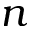Convert formula to latex. <formula><loc_0><loc_0><loc_500><loc_500>n</formula> 